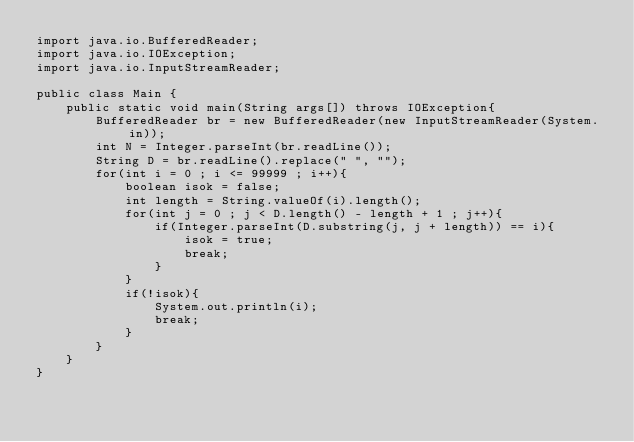<code> <loc_0><loc_0><loc_500><loc_500><_Java_>import java.io.BufferedReader;
import java.io.IOException;
import java.io.InputStreamReader;

public class Main {
	public static void main(String args[]) throws IOException{
		BufferedReader br = new BufferedReader(new InputStreamReader(System.in));
		int N = Integer.parseInt(br.readLine());
		String D = br.readLine().replace(" ", "");
		for(int i = 0 ; i <= 99999 ; i++){
			boolean isok = false;
			int length = String.valueOf(i).length();
			for(int j = 0 ; j < D.length() - length + 1 ; j++){
				if(Integer.parseInt(D.substring(j, j + length)) == i){
					isok = true;
					break;
				}
			}
			if(!isok){
				System.out.println(i);
				break;
			}
		}
	}
}</code> 